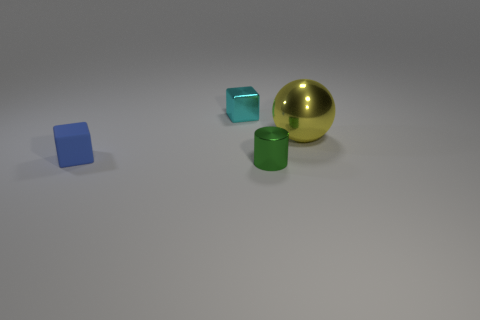Add 3 big cyan rubber cubes. How many objects exist? 7 Add 2 small metal objects. How many small metal objects are left? 4 Add 4 green shiny things. How many green shiny things exist? 5 Subtract 0 brown cylinders. How many objects are left? 4 Subtract all yellow objects. Subtract all big yellow shiny blocks. How many objects are left? 3 